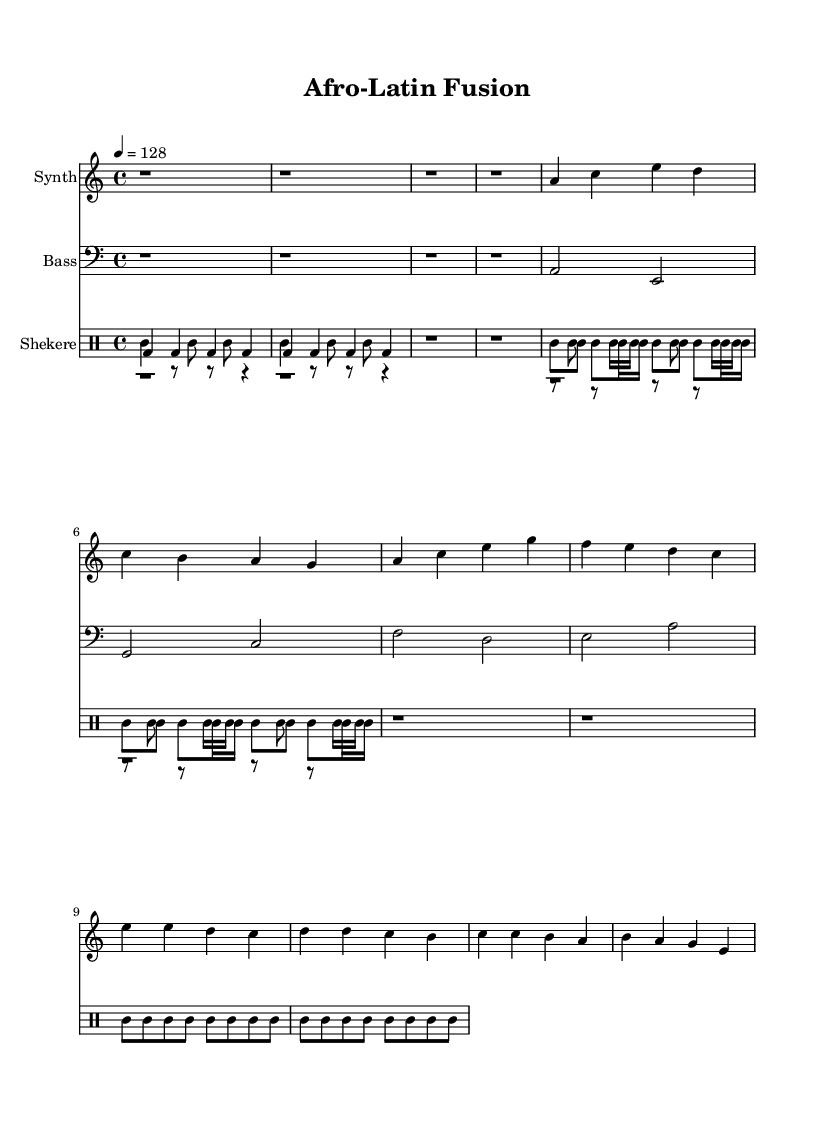What is the key signature of this music? The key signature is A minor, which contains no sharps or flats, indicating that all the notes should naturally fall within that scale.
Answer: A minor What is the time signature of this music? The time signature is 4/4, denoting that there are four beats in each measure and that each quarter note receives one beat.
Answer: 4/4 What is the tempo marking of this piece? The tempo is marked as 128 beats per minute, indicating a relatively fast pace for this composition.
Answer: 128 How many different drum voices are used in this sheet music? There are five different drum voices: Djembe, Conga, Bongo, Clave, and Shekere. Each contributes distinct percussive layers reflecting Afro-Latin rhythmic traditions.
Answer: 5 What rhythmic pattern does the clave follow in this music? The clave pattern is a repeating rhythm that typically emphasizes the second and fourth beats, which is characteristic of Afro-Latin music, playing a crucial role in the overall groove.
Answer: Clave Which instrument plays the lead melody in this piece? The lead melody is played by the Synth, which carries the primary melodic content that interacts with the rhythm provided by the drums and bass.
Answer: Synth How does the bass line contribute to the overall groove of this Afro-Latin House piece? The bass line establishes a harmonic foundation and complements the percussive elements, creating a rich groove that supports the rhythmic complexity of the piece while maintaining focus on the danceable aspects typical of House music.
Answer: Bass 